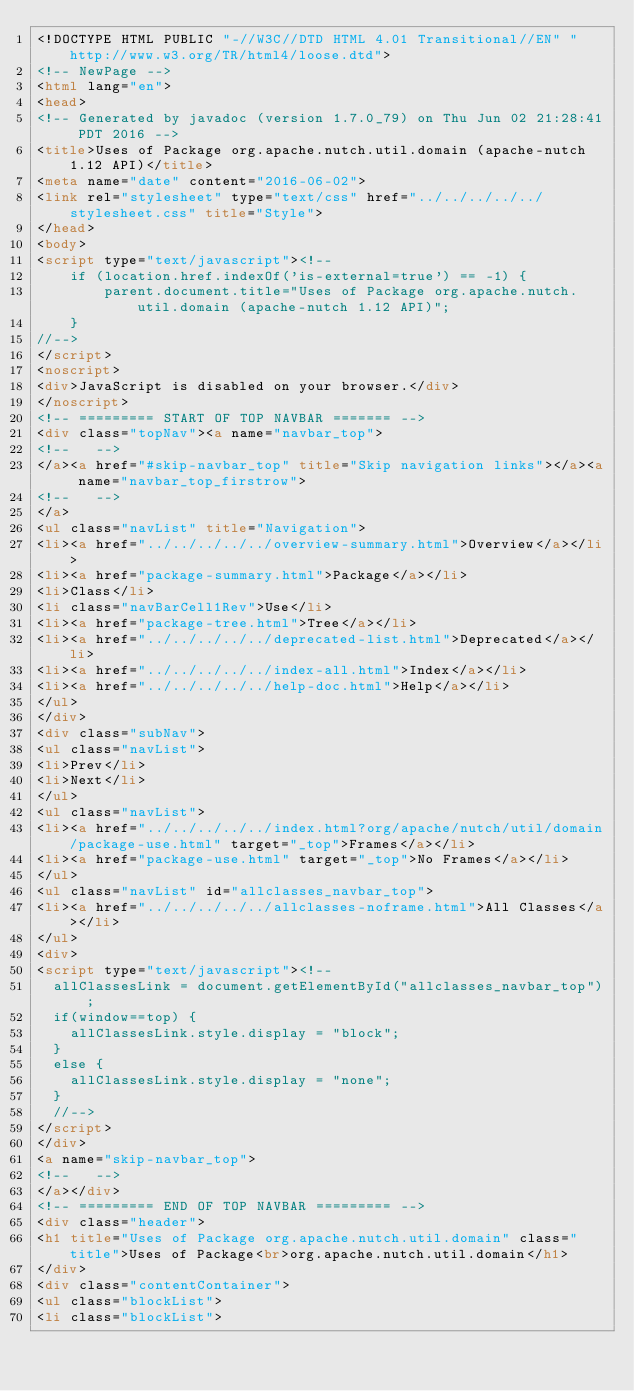<code> <loc_0><loc_0><loc_500><loc_500><_HTML_><!DOCTYPE HTML PUBLIC "-//W3C//DTD HTML 4.01 Transitional//EN" "http://www.w3.org/TR/html4/loose.dtd">
<!-- NewPage -->
<html lang="en">
<head>
<!-- Generated by javadoc (version 1.7.0_79) on Thu Jun 02 21:28:41 PDT 2016 -->
<title>Uses of Package org.apache.nutch.util.domain (apache-nutch 1.12 API)</title>
<meta name="date" content="2016-06-02">
<link rel="stylesheet" type="text/css" href="../../../../../stylesheet.css" title="Style">
</head>
<body>
<script type="text/javascript"><!--
    if (location.href.indexOf('is-external=true') == -1) {
        parent.document.title="Uses of Package org.apache.nutch.util.domain (apache-nutch 1.12 API)";
    }
//-->
</script>
<noscript>
<div>JavaScript is disabled on your browser.</div>
</noscript>
<!-- ========= START OF TOP NAVBAR ======= -->
<div class="topNav"><a name="navbar_top">
<!--   -->
</a><a href="#skip-navbar_top" title="Skip navigation links"></a><a name="navbar_top_firstrow">
<!--   -->
</a>
<ul class="navList" title="Navigation">
<li><a href="../../../../../overview-summary.html">Overview</a></li>
<li><a href="package-summary.html">Package</a></li>
<li>Class</li>
<li class="navBarCell1Rev">Use</li>
<li><a href="package-tree.html">Tree</a></li>
<li><a href="../../../../../deprecated-list.html">Deprecated</a></li>
<li><a href="../../../../../index-all.html">Index</a></li>
<li><a href="../../../../../help-doc.html">Help</a></li>
</ul>
</div>
<div class="subNav">
<ul class="navList">
<li>Prev</li>
<li>Next</li>
</ul>
<ul class="navList">
<li><a href="../../../../../index.html?org/apache/nutch/util/domain/package-use.html" target="_top">Frames</a></li>
<li><a href="package-use.html" target="_top">No Frames</a></li>
</ul>
<ul class="navList" id="allclasses_navbar_top">
<li><a href="../../../../../allclasses-noframe.html">All Classes</a></li>
</ul>
<div>
<script type="text/javascript"><!--
  allClassesLink = document.getElementById("allclasses_navbar_top");
  if(window==top) {
    allClassesLink.style.display = "block";
  }
  else {
    allClassesLink.style.display = "none";
  }
  //-->
</script>
</div>
<a name="skip-navbar_top">
<!--   -->
</a></div>
<!-- ========= END OF TOP NAVBAR ========= -->
<div class="header">
<h1 title="Uses of Package org.apache.nutch.util.domain" class="title">Uses of Package<br>org.apache.nutch.util.domain</h1>
</div>
<div class="contentContainer">
<ul class="blockList">
<li class="blockList"></code> 